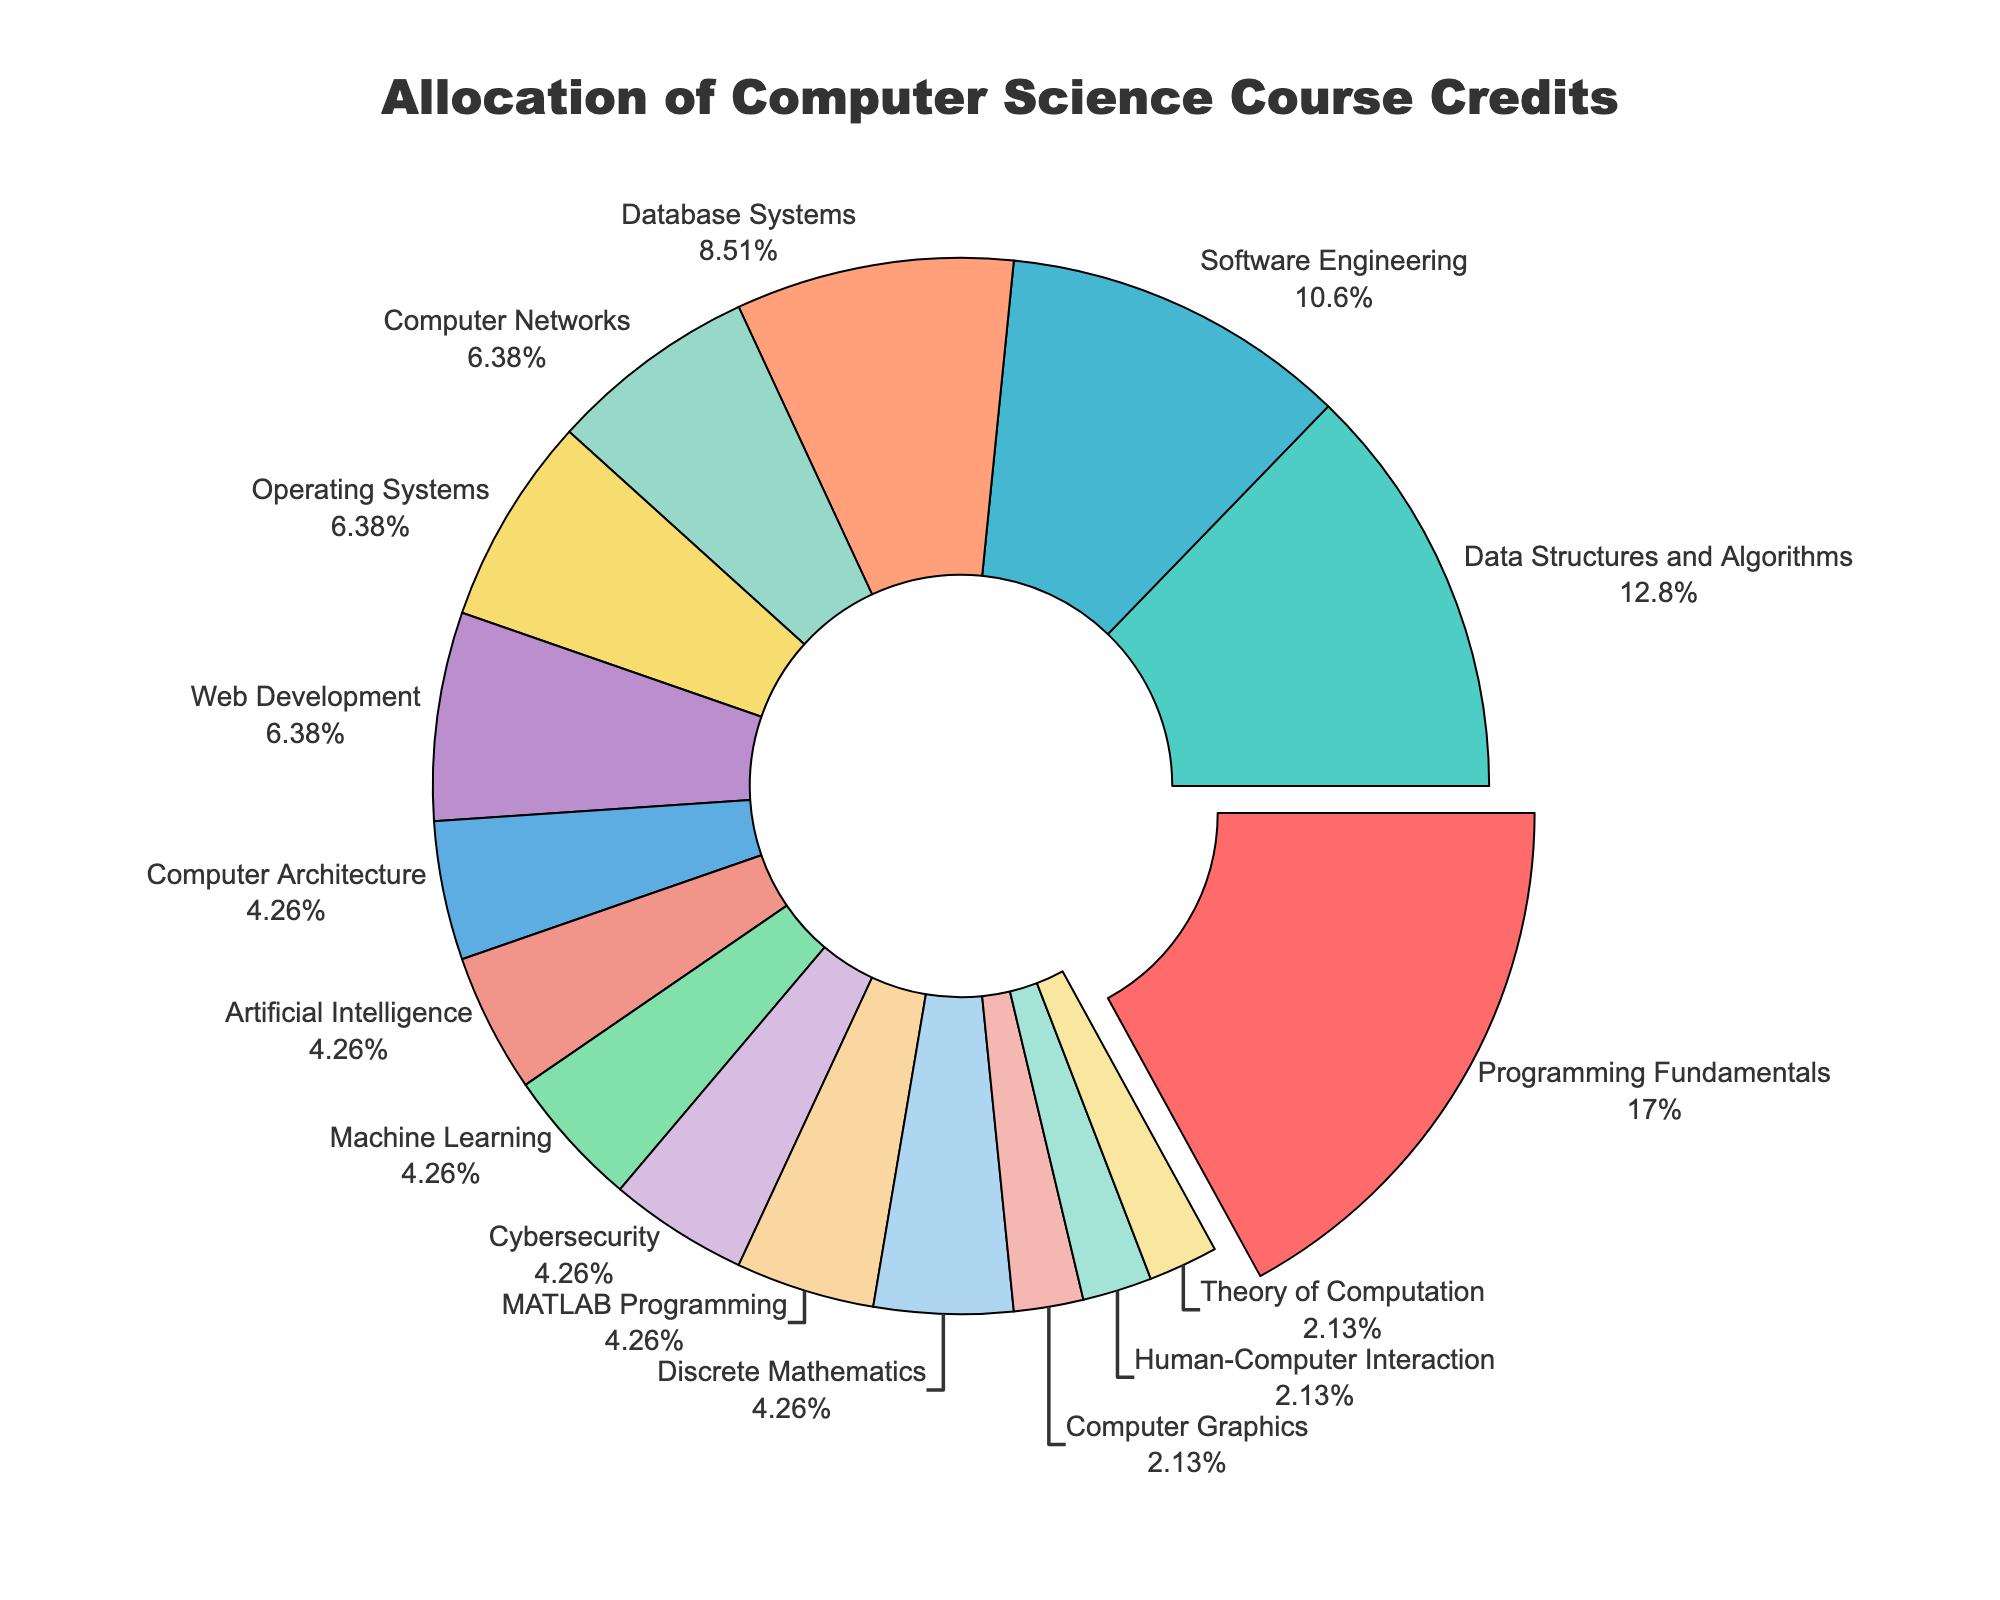What's the subject area with the highest allocation of credits? The figure shows that 'Programming Fundamentals' has the largest segment of the pie chart, which indicates the highest number of credits allocated.
Answer: Programming Fundamentals How many subject areas have an equal allocation of credits? The pie chart shows segments with the same size. There are several subjects with 6 credits each, including Machine Learning, Artificial Intelligence, Cybersecurity, Computer Architecture, Discrete Mathematics, and MATLAB Programming. Similarly, there are subjects with 3 credits each, like Human-Computer Interaction and Theory of Computation.
Answer: 9 What's the total number of credits for subjects with fewer than 10 credits? To find the total credits for subjects with fewer than 10 credits, we sum credits for Computer Networks (9), Operating Systems (9), Web Development (9), Computer Architecture (6), Artificial Intelligence (6), Machine Learning (6), Cybersecurity (6), Computer Graphics (3), Human-Computer Interaction (3), MATLAB Programming (6), and Theory of Computation (3). The total is 66.
Answer: 66 Which subject area represents the smallest portion of the pie chart? By observing the smallest segments in the pie chart, 'Computer Graphics,' 'Human-Computer Interaction,' and 'Theory of Computation' appear to be the smallest, each contributing 3 credits.
Answer: Computer Graphics, Human-Computer Interaction, Theory of Computation What percentage of the total credits is allocated to 'Data Structures and Algorithms'? The percentage can be obtained by looking at the pie chart's label. 'Data Structures and Algorithms' contributes 18 credits out of the total sum, which is around 10.1%.
Answer: 10.1% How many more credits are allocated to 'Programming Fundamentals' compared to 'Software Engineering'? The segment size shows 'Programming Fundamentals' with 24 credits and 'Software Engineering' with 15 credits. The difference is 24 - 15 = 9 credits.
Answer: 9 Which two subject areas have a combined total credit equal to that of 'Programming Fundamentals'? We need to find two subjects whose combined credits add up to 24. 'Data Structures and Algorithms' (18 credits) and 'Artificial Intelligence' (6 credits) together make 24 credits.
Answer: Data Structures and Algorithms, Artificial Intelligence What's the average number of credits for all subject areas? First, sum all the credits: 24 + 18 + 15 + 12 + 9 + 9 + 6 + 9 + 6 + 6 + 6 + 3 + 3 + 6 + 3 + 6 = 141. There are 16 subject areas, so the average is 141 / 16 = 8.8125.
Answer: 8.8125 What is the difference in the number of credits allocated to 'Database Systems' and 'Web Development'? The segment for 'Database Systems' shows 12 credits, and 'Web Development' shows 9 credits. The difference is 12 - 9 = 3.
Answer: 3 Which color represents 'Cybersecurity' in the pie chart? By examining the pie chart and identifying the color segment corresponding to the label 'Cybersecurity,' we can see that it is represented by a specific color shade.
Answer: Color related to 'Cybersecurity' 